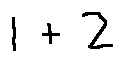<formula> <loc_0><loc_0><loc_500><loc_500>1 + 2</formula> 